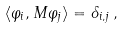<formula> <loc_0><loc_0><loc_500><loc_500>\langle \varphi _ { i } , M \varphi _ { j } \rangle = \delta _ { i , j } \, ,</formula> 